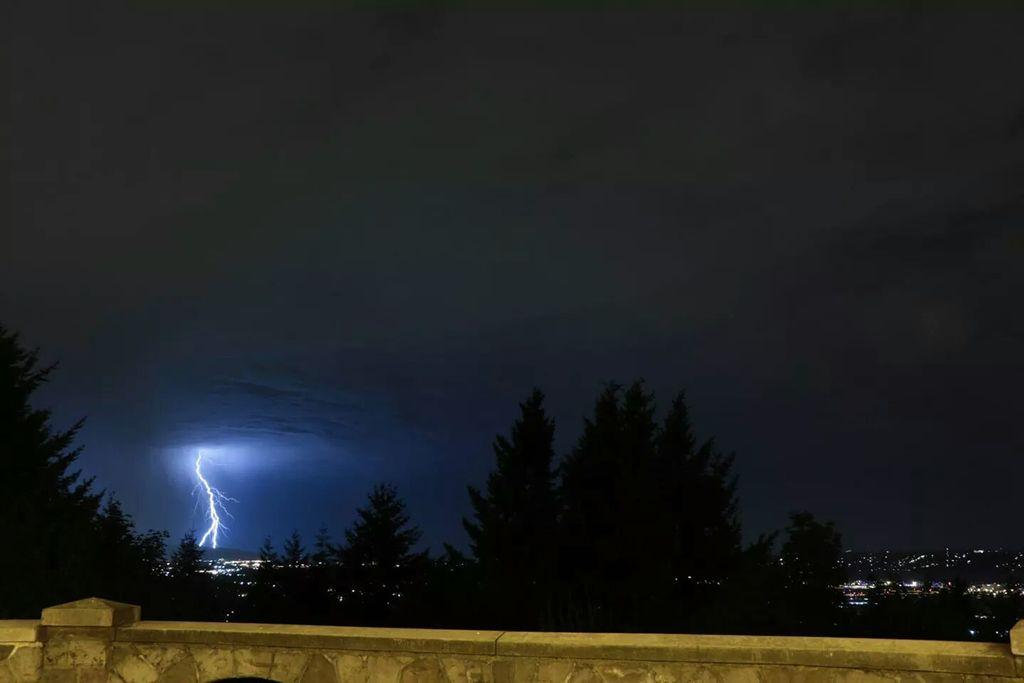What type of structure can be seen in the image? There is a wall in the image. What natural elements are present in the image? There are trees in the image. What artificial elements are present in the image? There are lights in the image. What can be seen in the background of the image? The sky is visible in the background of the image. Can you hear thunder in the image? There is no sound present in the image, so it is not possible to hear thunder. What type of shop is located near the wall in the image? There is no shop mentioned or visible in the image. 